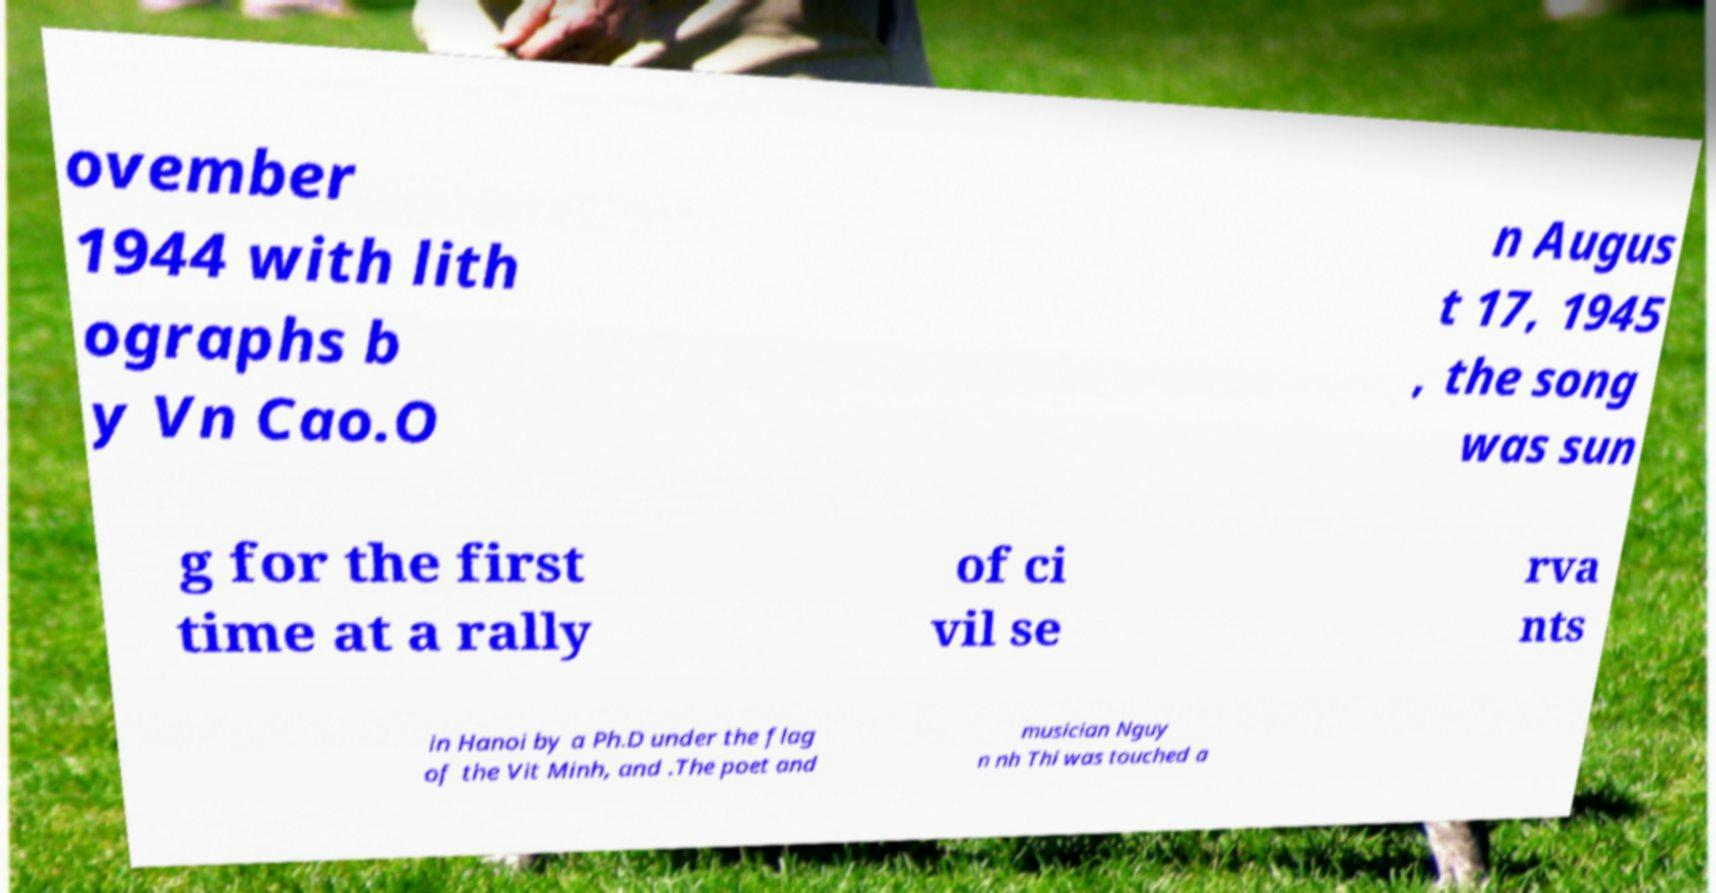Could you extract and type out the text from this image? ovember 1944 with lith ographs b y Vn Cao.O n Augus t 17, 1945 , the song was sun g for the first time at a rally of ci vil se rva nts in Hanoi by a Ph.D under the flag of the Vit Minh, and .The poet and musician Nguy n nh Thi was touched a 